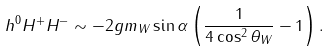<formula> <loc_0><loc_0><loc_500><loc_500>h ^ { 0 } H ^ { + } H ^ { - } \sim - 2 g m _ { W } \sin \alpha \left ( \frac { 1 } { 4 \cos ^ { 2 } \theta _ { W } } - 1 \right ) .</formula> 